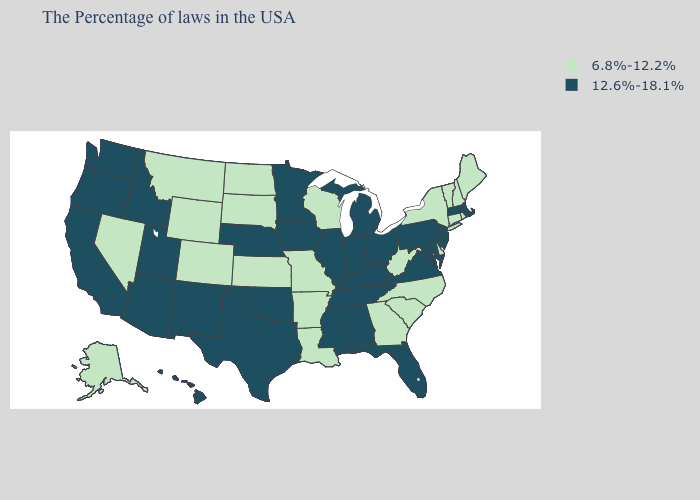Is the legend a continuous bar?
Give a very brief answer. No. Does Louisiana have the highest value in the South?
Quick response, please. No. What is the lowest value in the USA?
Answer briefly. 6.8%-12.2%. What is the lowest value in the USA?
Give a very brief answer. 6.8%-12.2%. What is the value of Missouri?
Keep it brief. 6.8%-12.2%. Which states have the highest value in the USA?
Answer briefly. Massachusetts, New Jersey, Maryland, Pennsylvania, Virginia, Ohio, Florida, Michigan, Kentucky, Indiana, Alabama, Tennessee, Illinois, Mississippi, Minnesota, Iowa, Nebraska, Oklahoma, Texas, New Mexico, Utah, Arizona, Idaho, California, Washington, Oregon, Hawaii. What is the value of Idaho?
Give a very brief answer. 12.6%-18.1%. What is the value of Virginia?
Answer briefly. 12.6%-18.1%. What is the value of Iowa?
Concise answer only. 12.6%-18.1%. Which states have the highest value in the USA?
Quick response, please. Massachusetts, New Jersey, Maryland, Pennsylvania, Virginia, Ohio, Florida, Michigan, Kentucky, Indiana, Alabama, Tennessee, Illinois, Mississippi, Minnesota, Iowa, Nebraska, Oklahoma, Texas, New Mexico, Utah, Arizona, Idaho, California, Washington, Oregon, Hawaii. Name the states that have a value in the range 6.8%-12.2%?
Write a very short answer. Maine, Rhode Island, New Hampshire, Vermont, Connecticut, New York, Delaware, North Carolina, South Carolina, West Virginia, Georgia, Wisconsin, Louisiana, Missouri, Arkansas, Kansas, South Dakota, North Dakota, Wyoming, Colorado, Montana, Nevada, Alaska. What is the value of North Dakota?
Quick response, please. 6.8%-12.2%. What is the value of Louisiana?
Quick response, please. 6.8%-12.2%. Does Oregon have the same value as Alaska?
Concise answer only. No. 